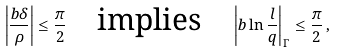<formula> <loc_0><loc_0><loc_500><loc_500>\left | \frac { b \delta } { \rho } \right | \leq \frac { \pi } { 2 } \quad \text {implies} \quad \left | b \ln \frac { l } { q } \right | _ { \Gamma } \leq \frac { \pi } { 2 } \, ,</formula> 